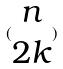Convert formula to latex. <formula><loc_0><loc_0><loc_500><loc_500>( \begin{matrix} n \\ 2 k \end{matrix} )</formula> 